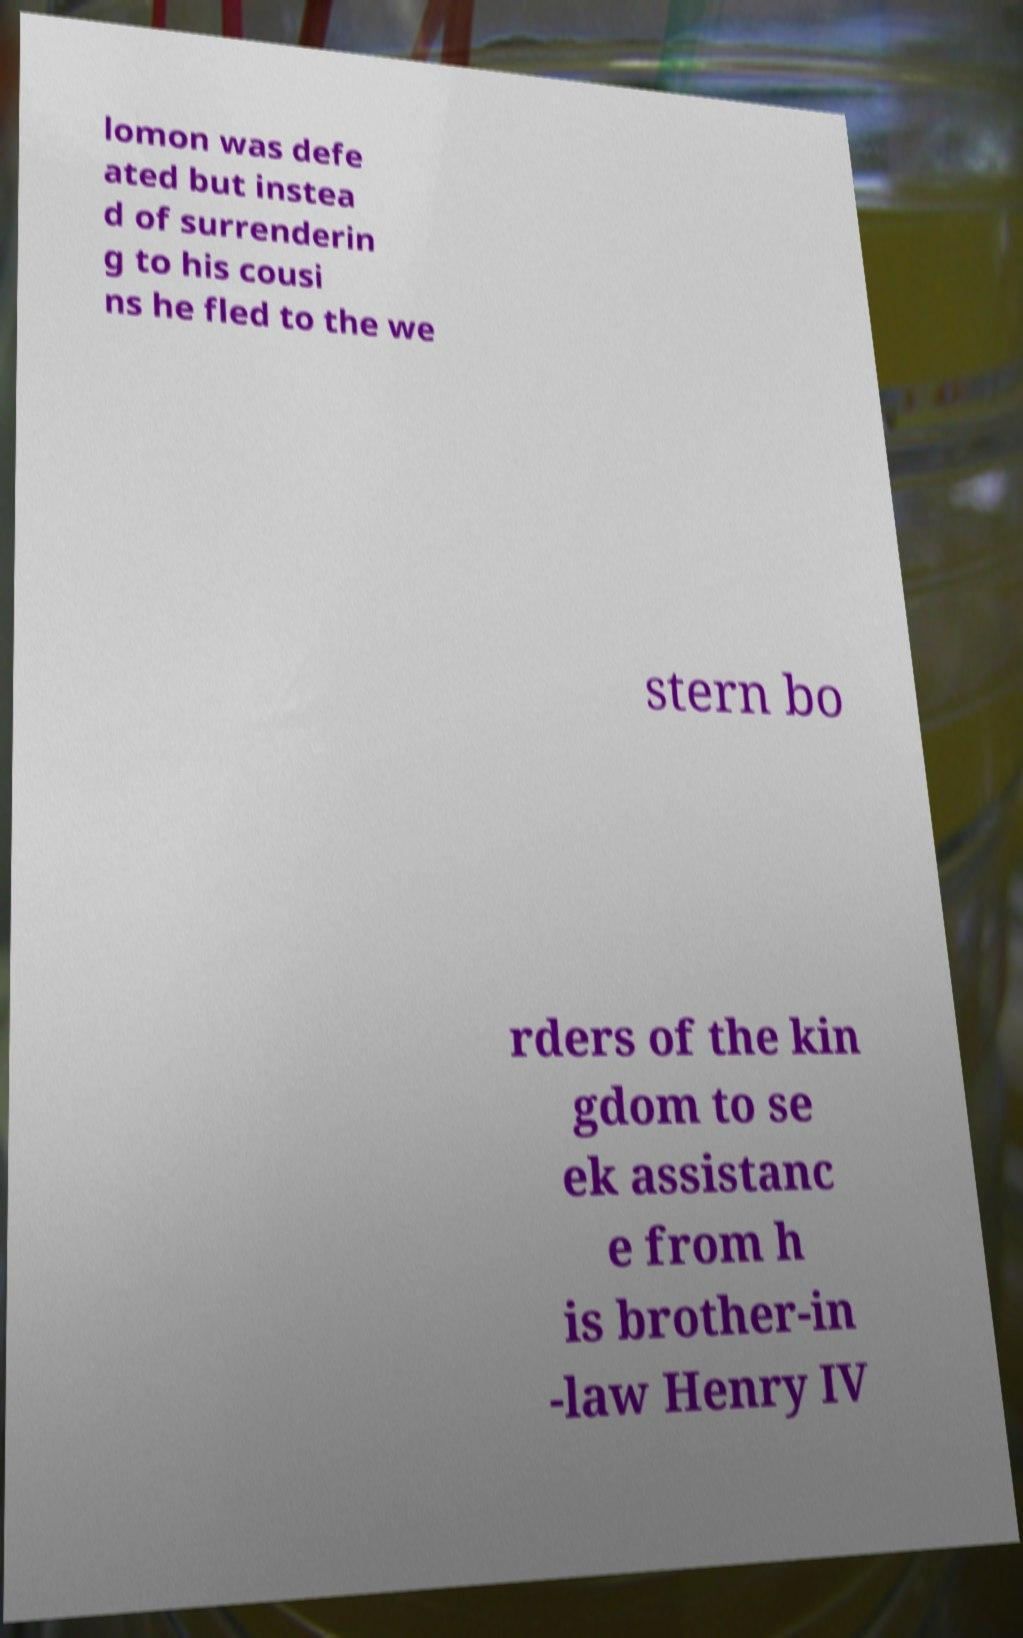Can you read and provide the text displayed in the image?This photo seems to have some interesting text. Can you extract and type it out for me? lomon was defe ated but instea d of surrenderin g to his cousi ns he fled to the we stern bo rders of the kin gdom to se ek assistanc e from h is brother-in -law Henry IV 